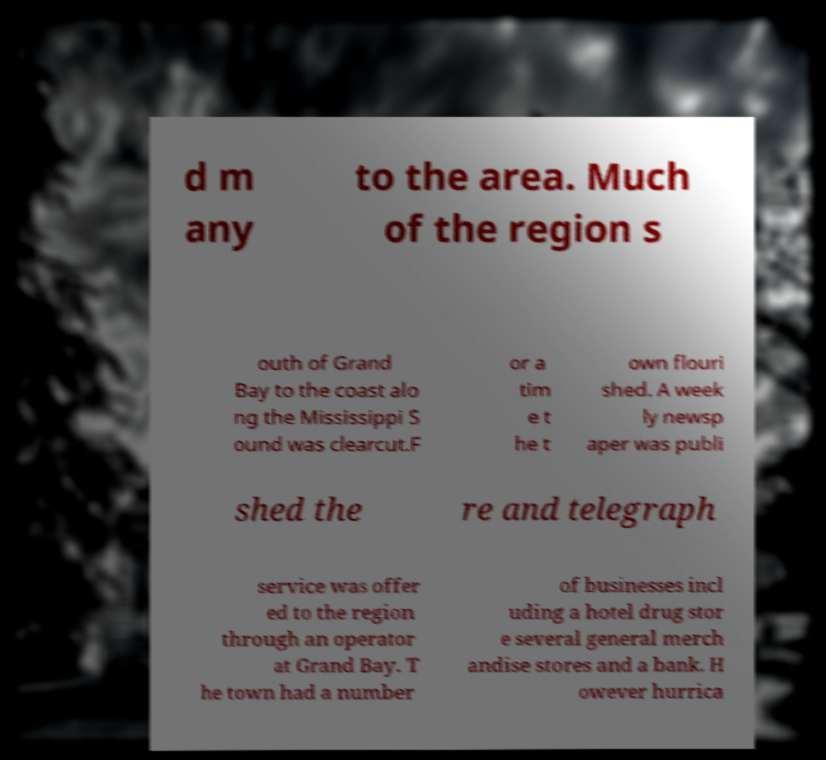Could you assist in decoding the text presented in this image and type it out clearly? d m any to the area. Much of the region s outh of Grand Bay to the coast alo ng the Mississippi S ound was clearcut.F or a tim e t he t own flouri shed. A week ly newsp aper was publi shed the re and telegraph service was offer ed to the region through an operator at Grand Bay. T he town had a number of businesses incl uding a hotel drug stor e several general merch andise stores and a bank. H owever hurrica 